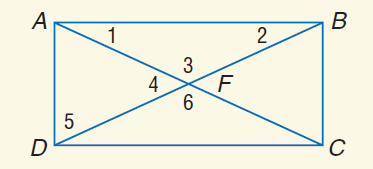Question: A B C D is a rectangle. If A C = 9 x - 1 and A F = 2 x + 7, find A F.
Choices:
A. 3
B. 6
C. 13
D. 26
Answer with the letter. Answer: C Question: If m \angle 2 = 70 - 4 x and m \angle 5 = 18 x - 8, find m \angle 5.
Choices:
A. 2
B. 28
C. 62
D. 72
Answer with the letter. Answer: B 